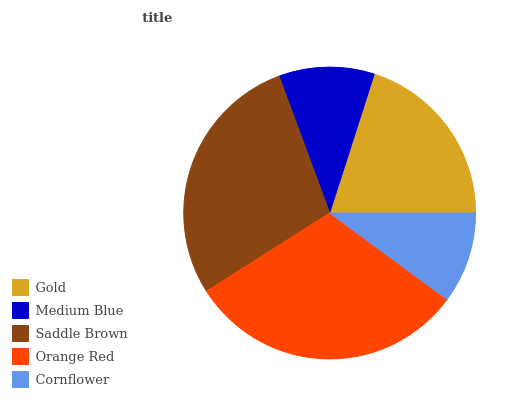Is Cornflower the minimum?
Answer yes or no. Yes. Is Orange Red the maximum?
Answer yes or no. Yes. Is Medium Blue the minimum?
Answer yes or no. No. Is Medium Blue the maximum?
Answer yes or no. No. Is Gold greater than Medium Blue?
Answer yes or no. Yes. Is Medium Blue less than Gold?
Answer yes or no. Yes. Is Medium Blue greater than Gold?
Answer yes or no. No. Is Gold less than Medium Blue?
Answer yes or no. No. Is Gold the high median?
Answer yes or no. Yes. Is Gold the low median?
Answer yes or no. Yes. Is Medium Blue the high median?
Answer yes or no. No. Is Orange Red the low median?
Answer yes or no. No. 